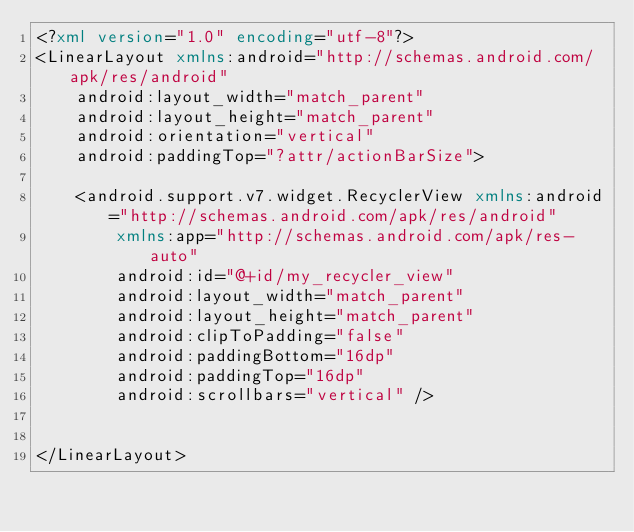Convert code to text. <code><loc_0><loc_0><loc_500><loc_500><_XML_><?xml version="1.0" encoding="utf-8"?>
<LinearLayout xmlns:android="http://schemas.android.com/apk/res/android"
    android:layout_width="match_parent"
    android:layout_height="match_parent"
    android:orientation="vertical"
    android:paddingTop="?attr/actionBarSize">

    <android.support.v7.widget.RecyclerView xmlns:android="http://schemas.android.com/apk/res/android"
        xmlns:app="http://schemas.android.com/apk/res-auto"
        android:id="@+id/my_recycler_view"
        android:layout_width="match_parent"
        android:layout_height="match_parent"
        android:clipToPadding="false"
        android:paddingBottom="16dp"
        android:paddingTop="16dp"
        android:scrollbars="vertical" />


</LinearLayout></code> 